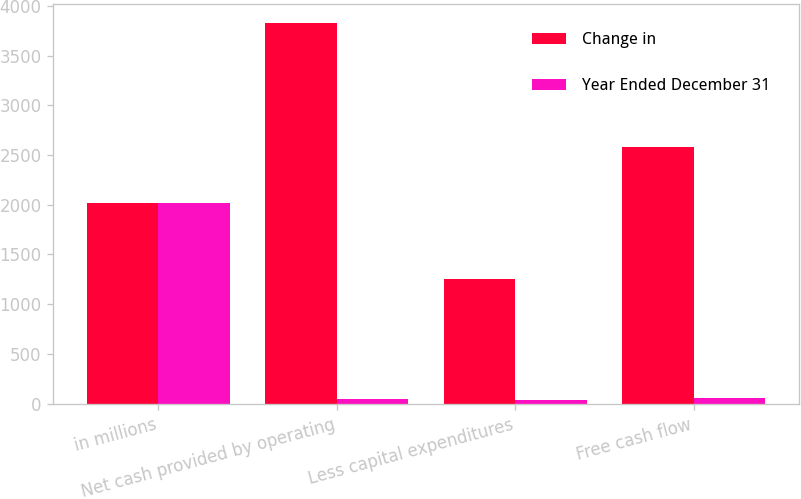Convert chart. <chart><loc_0><loc_0><loc_500><loc_500><stacked_bar_chart><ecel><fcel>in millions<fcel>Net cash provided by operating<fcel>Less capital expenditures<fcel>Free cash flow<nl><fcel>Change in<fcel>2018<fcel>3827<fcel>1249<fcel>2578<nl><fcel>Year Ended December 31<fcel>2018<fcel>46<fcel>35<fcel>53<nl></chart> 